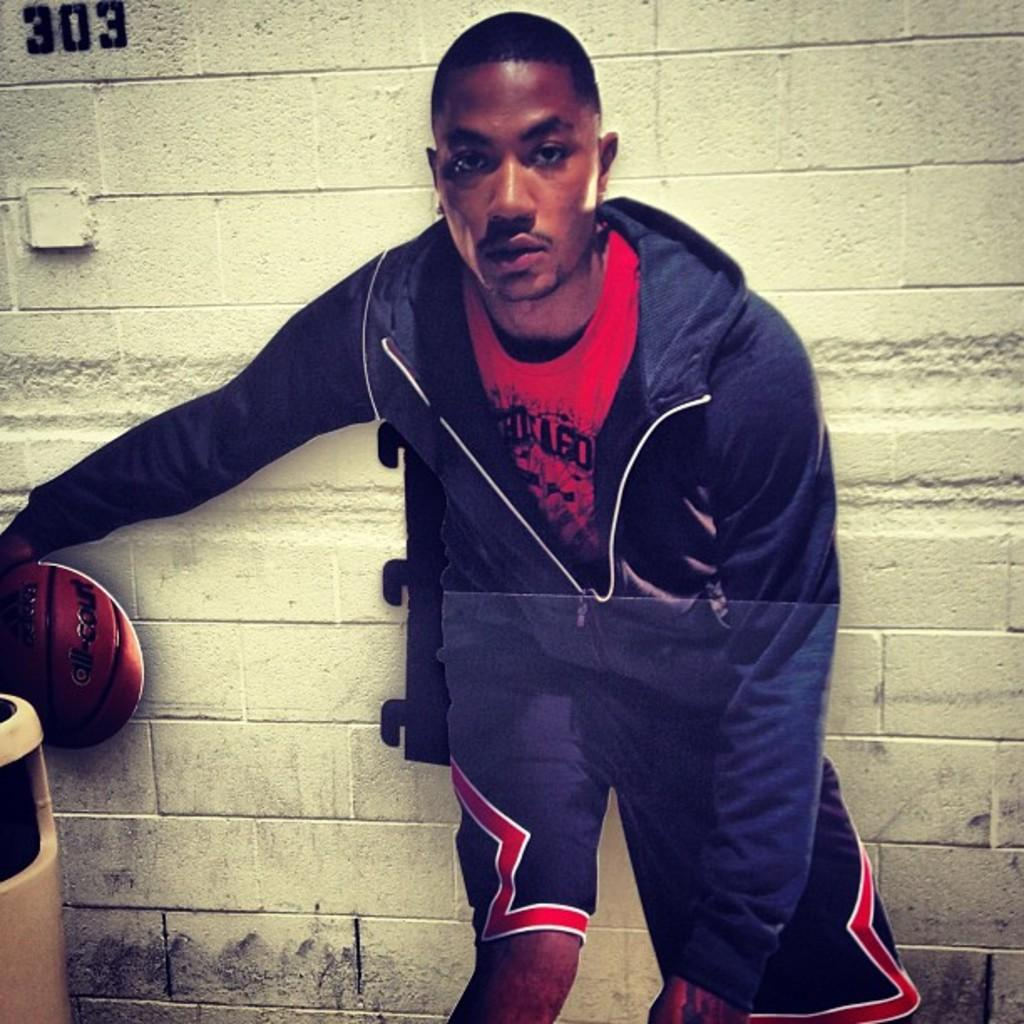Provide a one-sentence caption for the provided image. A young man stands in front of a wall with 303 painted on the upper left corner. 